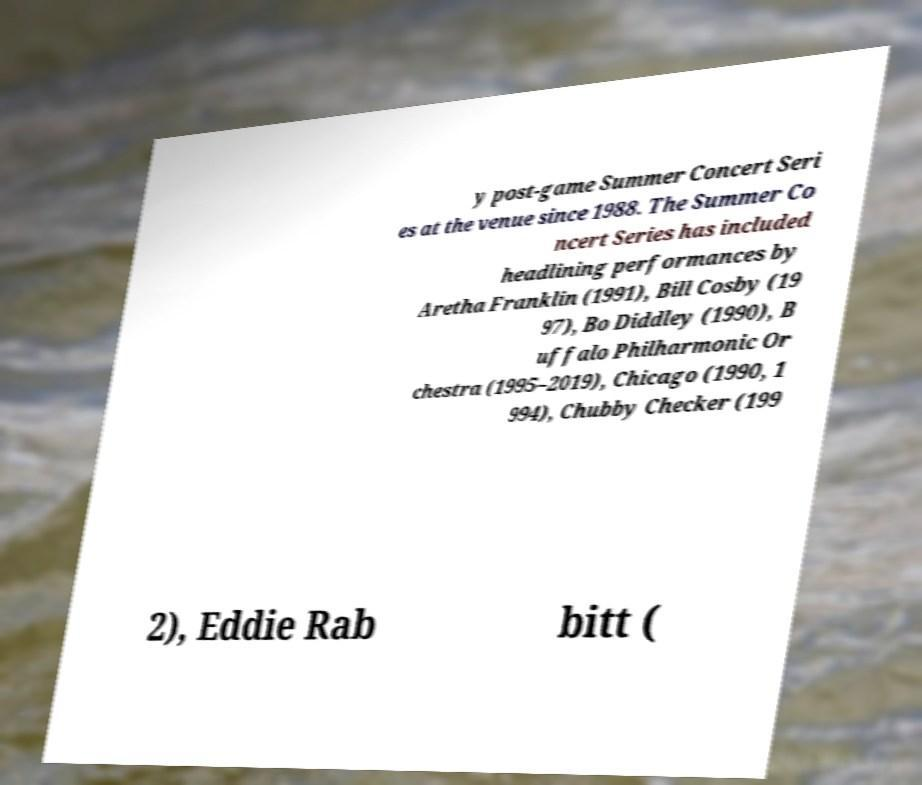Could you assist in decoding the text presented in this image and type it out clearly? y post-game Summer Concert Seri es at the venue since 1988. The Summer Co ncert Series has included headlining performances by Aretha Franklin (1991), Bill Cosby (19 97), Bo Diddley (1990), B uffalo Philharmonic Or chestra (1995–2019), Chicago (1990, 1 994), Chubby Checker (199 2), Eddie Rab bitt ( 